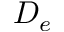Convert formula to latex. <formula><loc_0><loc_0><loc_500><loc_500>D _ { e }</formula> 